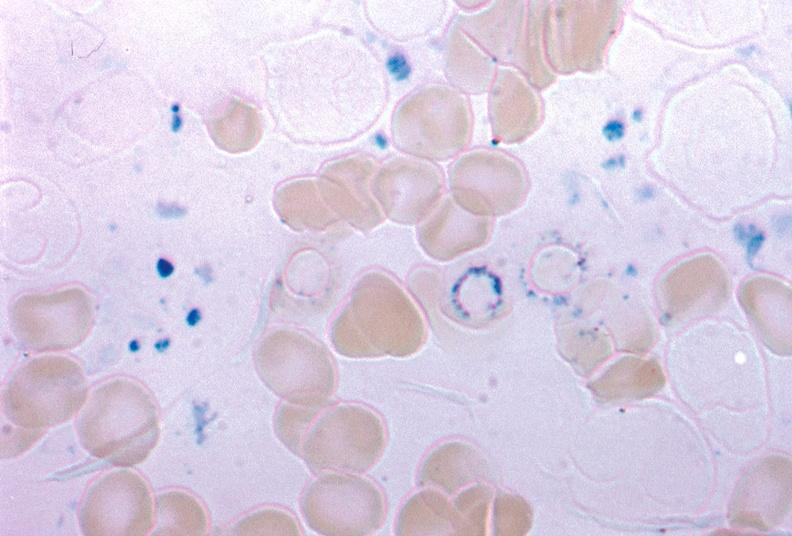does this image show iron stain excellent example source unknown?
Answer the question using a single word or phrase. Yes 